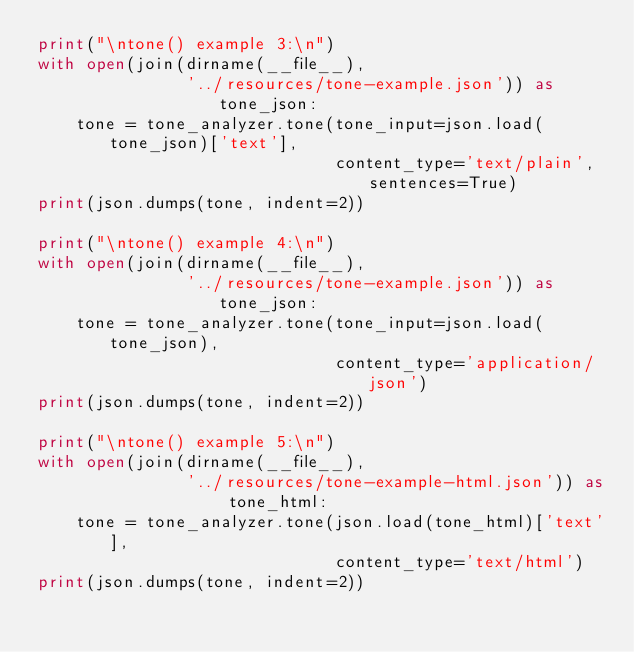<code> <loc_0><loc_0><loc_500><loc_500><_Python_>print("\ntone() example 3:\n")
with open(join(dirname(__file__),
               '../resources/tone-example.json')) as tone_json:
    tone = tone_analyzer.tone(tone_input=json.load(tone_json)['text'],
                              content_type='text/plain', sentences=True)
print(json.dumps(tone, indent=2))

print("\ntone() example 4:\n")
with open(join(dirname(__file__),
               '../resources/tone-example.json')) as tone_json:
    tone = tone_analyzer.tone(tone_input=json.load(tone_json),
                              content_type='application/json')
print(json.dumps(tone, indent=2))

print("\ntone() example 5:\n")
with open(join(dirname(__file__),
               '../resources/tone-example-html.json')) as tone_html:
    tone = tone_analyzer.tone(json.load(tone_html)['text'],
                              content_type='text/html')
print(json.dumps(tone, indent=2))
</code> 